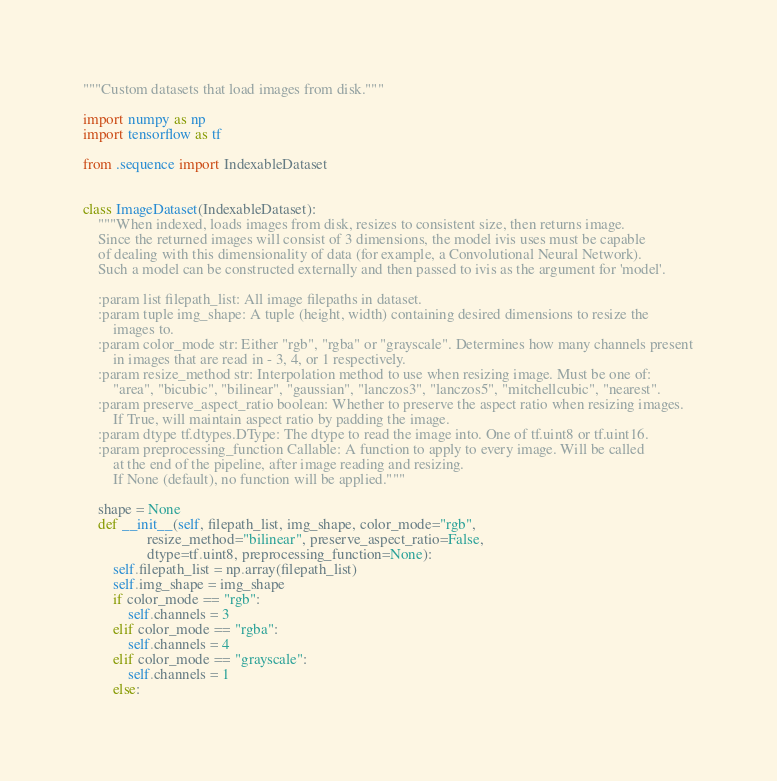Convert code to text. <code><loc_0><loc_0><loc_500><loc_500><_Python_>"""Custom datasets that load images from disk."""

import numpy as np
import tensorflow as tf

from .sequence import IndexableDataset


class ImageDataset(IndexableDataset):
    """When indexed, loads images from disk, resizes to consistent size, then returns image.
    Since the returned images will consist of 3 dimensions, the model ivis uses must be capable
    of dealing with this dimensionality of data (for example, a Convolutional Neural Network).
    Such a model can be constructed externally and then passed to ivis as the argument for 'model'.

    :param list filepath_list: All image filepaths in dataset.
    :param tuple img_shape: A tuple (height, width) containing desired dimensions to resize the
        images to.
    :param color_mode str: Either "rgb", "rgba" or "grayscale". Determines how many channels present
        in images that are read in - 3, 4, or 1 respectively.
    :param resize_method str: Interpolation method to use when resizing image. Must be one of:
        "area", "bicubic", "bilinear", "gaussian", "lanczos3", "lanczos5", "mitchellcubic", "nearest".
    :param preserve_aspect_ratio boolean: Whether to preserve the aspect ratio when resizing images.
        If True, will maintain aspect ratio by padding the image.
    :param dtype tf.dtypes.DType: The dtype to read the image into. One of tf.uint8 or tf.uint16.
    :param preprocessing_function Callable: A function to apply to every image. Will be called
        at the end of the pipeline, after image reading and resizing.
        If None (default), no function will be applied."""

    shape = None
    def __init__(self, filepath_list, img_shape, color_mode="rgb",
                 resize_method="bilinear", preserve_aspect_ratio=False,
                 dtype=tf.uint8, preprocessing_function=None):
        self.filepath_list = np.array(filepath_list)
        self.img_shape = img_shape
        if color_mode == "rgb":
            self.channels = 3
        elif color_mode == "rgba":
            self.channels = 4
        elif color_mode == "grayscale":
            self.channels = 1
        else:</code> 